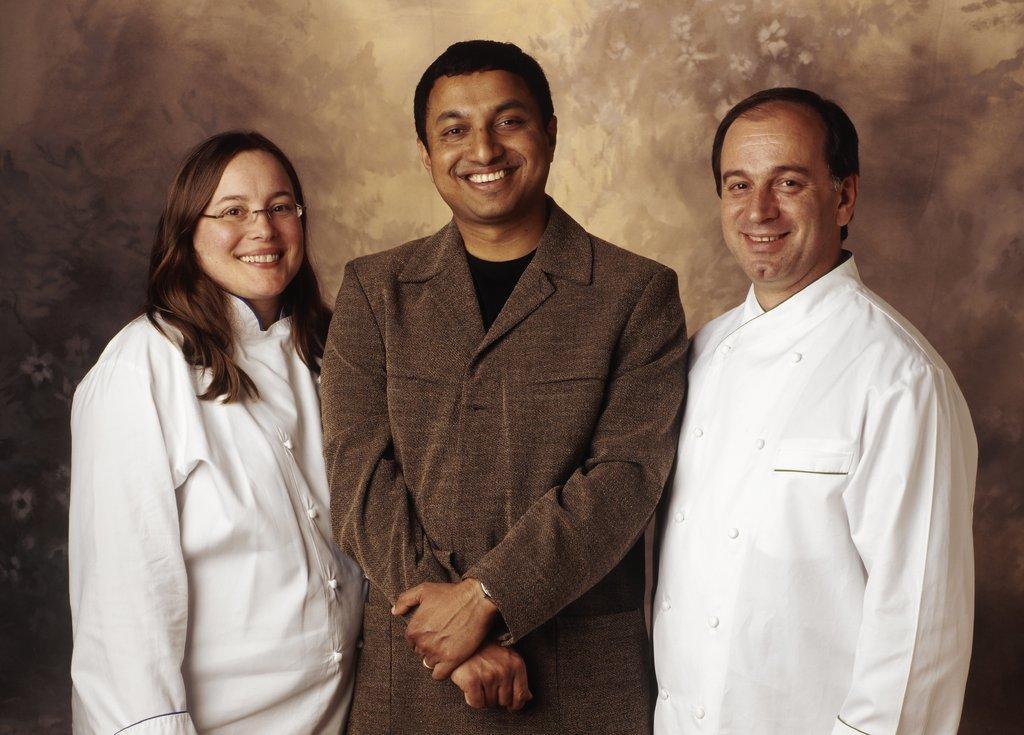Please provide a concise description of this image. In this image we can see three persons two are wearing white color dress and a person wearing brown color suit standing in the middle of the image is male and two persons wearing white color dress both are of opposite gender and in the background of the image we can see curtain. 